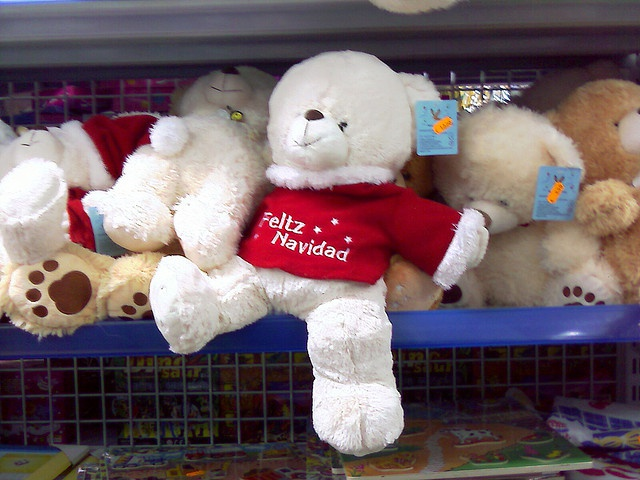Describe the objects in this image and their specific colors. I can see teddy bear in lightblue, lightgray, brown, darkgray, and maroon tones, teddy bear in lightblue, gray, and darkgray tones, teddy bear in lightblue, white, gray, darkgray, and lightgray tones, teddy bear in lightblue, white, tan, maroon, and darkgray tones, and teddy bear in lightblue, gray, tan, and brown tones in this image. 